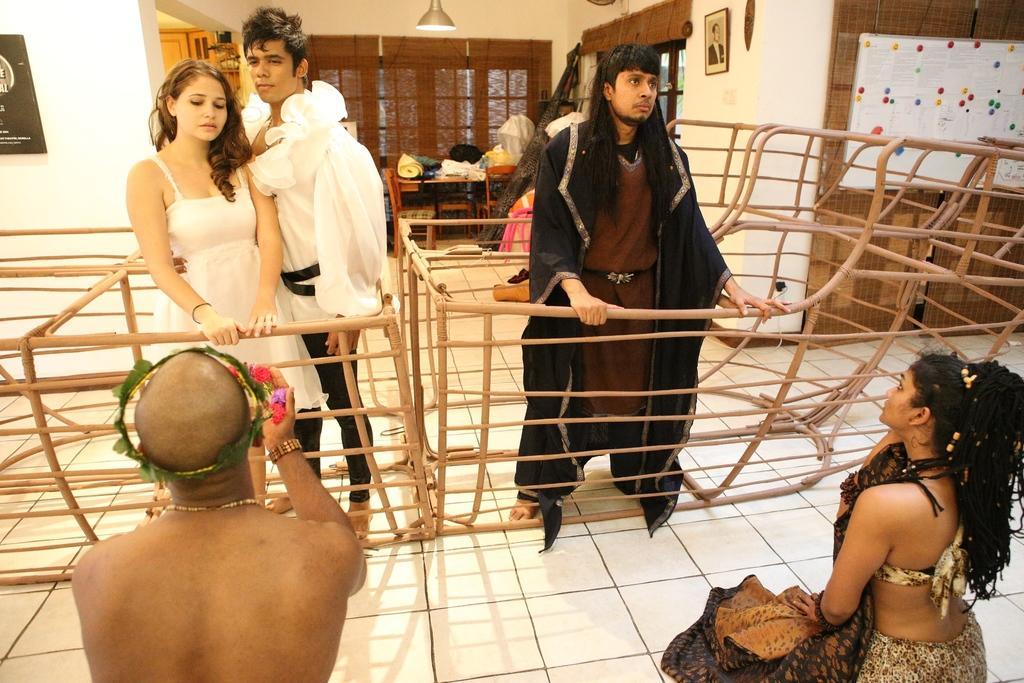Please provide a concise description of this image. In this picture I can see 5 persons in which these 2 persons are sitting and these 3 persons are standing. In the background I see the wall and I see the light on the top and on the right side of this image I see the photo frame on this wall and I see the white color board on which there are different color things. 